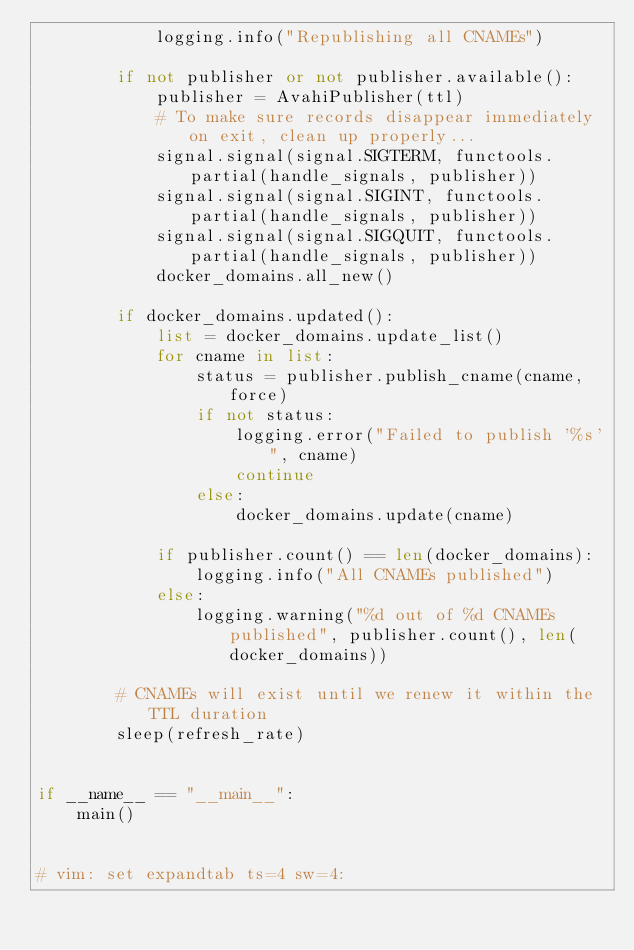<code> <loc_0><loc_0><loc_500><loc_500><_Python_>            logging.info("Republishing all CNAMEs")

        if not publisher or not publisher.available():
            publisher = AvahiPublisher(ttl)
            # To make sure records disappear immediately on exit, clean up properly...
            signal.signal(signal.SIGTERM, functools.partial(handle_signals, publisher))
            signal.signal(signal.SIGINT, functools.partial(handle_signals, publisher))
            signal.signal(signal.SIGQUIT, functools.partial(handle_signals, publisher))
            docker_domains.all_new()

        if docker_domains.updated():
            list = docker_domains.update_list()
            for cname in list:
                status = publisher.publish_cname(cname, force)
                if not status:
                    logging.error("Failed to publish '%s'", cname)
                    continue
                else:
                    docker_domains.update(cname)

            if publisher.count() == len(docker_domains):
                logging.info("All CNAMEs published")
            else:
                logging.warning("%d out of %d CNAMEs published", publisher.count(), len(docker_domains))

        # CNAMEs will exist until we renew it within the TTL duration
        sleep(refresh_rate)


if __name__ == "__main__":
    main()


# vim: set expandtab ts=4 sw=4:
</code> 